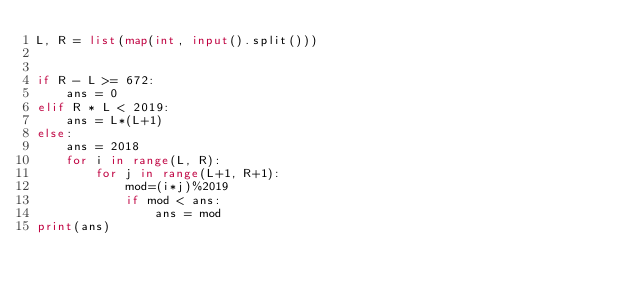Convert code to text. <code><loc_0><loc_0><loc_500><loc_500><_Python_>L, R = list(map(int, input().split()))  


if R - L >= 672:
    ans = 0
elif R * L < 2019:
    ans = L*(L+1)
else:
    ans = 2018
    for i in range(L, R):
        for j in range(L+1, R+1):
            mod=(i*j)%2019
            if mod < ans:
                ans = mod
print(ans)</code> 